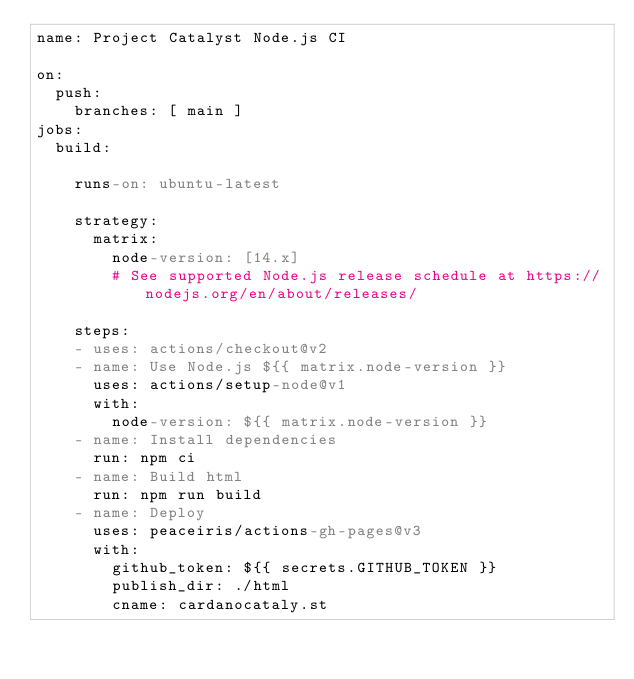<code> <loc_0><loc_0><loc_500><loc_500><_YAML_>name: Project Catalyst Node.js CI 

on:
  push:
    branches: [ main ]
jobs:
  build:

    runs-on: ubuntu-latest

    strategy:
      matrix:
        node-version: [14.x]
        # See supported Node.js release schedule at https://nodejs.org/en/about/releases/

    steps:
    - uses: actions/checkout@v2
    - name: Use Node.js ${{ matrix.node-version }}
      uses: actions/setup-node@v1
      with:
        node-version: ${{ matrix.node-version }}
    - name: Install dependencies
      run: npm ci
    - name: Build html 
      run: npm run build
    - name: Deploy
      uses: peaceiris/actions-gh-pages@v3
      with:
        github_token: ${{ secrets.GITHUB_TOKEN }}
        publish_dir: ./html
        cname: cardanocataly.st</code> 